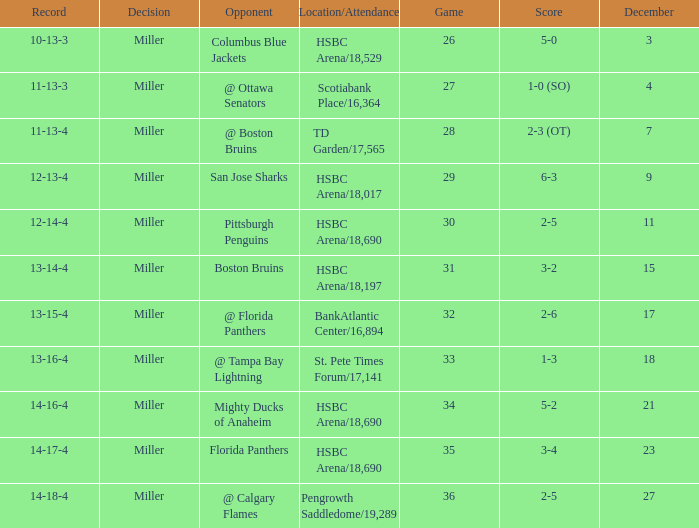Name the least december for hsbc arena/18,017 9.0. Could you help me parse every detail presented in this table? {'header': ['Record', 'Decision', 'Opponent', 'Location/Attendance', 'Game', 'Score', 'December'], 'rows': [['10-13-3', 'Miller', 'Columbus Blue Jackets', 'HSBC Arena/18,529', '26', '5-0', '3'], ['11-13-3', 'Miller', '@ Ottawa Senators', 'Scotiabank Place/16,364', '27', '1-0 (SO)', '4'], ['11-13-4', 'Miller', '@ Boston Bruins', 'TD Garden/17,565', '28', '2-3 (OT)', '7'], ['12-13-4', 'Miller', 'San Jose Sharks', 'HSBC Arena/18,017', '29', '6-3', '9'], ['12-14-4', 'Miller', 'Pittsburgh Penguins', 'HSBC Arena/18,690', '30', '2-5', '11'], ['13-14-4', 'Miller', 'Boston Bruins', 'HSBC Arena/18,197', '31', '3-2', '15'], ['13-15-4', 'Miller', '@ Florida Panthers', 'BankAtlantic Center/16,894', '32', '2-6', '17'], ['13-16-4', 'Miller', '@ Tampa Bay Lightning', 'St. Pete Times Forum/17,141', '33', '1-3', '18'], ['14-16-4', 'Miller', 'Mighty Ducks of Anaheim', 'HSBC Arena/18,690', '34', '5-2', '21'], ['14-17-4', 'Miller', 'Florida Panthers', 'HSBC Arena/18,690', '35', '3-4', '23'], ['14-18-4', 'Miller', '@ Calgary Flames', 'Pengrowth Saddledome/19,289', '36', '2-5', '27']]} 